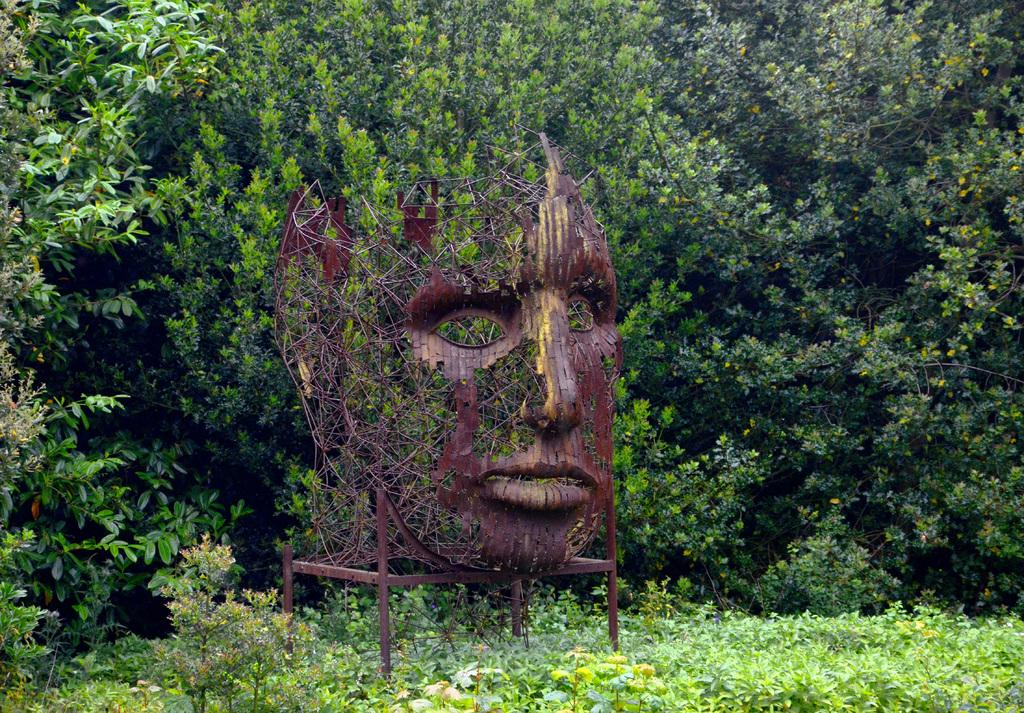What is the main subject of the image? There is a depiction of a person in the center of the image. What can be seen in the background of the image? There are trees in the background of the image. What type of vegetation is at the bottom of the image? There are plants at the bottom of the image. What color is the kite flying in the image? There is no kite present in the image. How does the stone affect the person's movement in the image? There is no stone present in the image, so it does not affect the person's movement. 